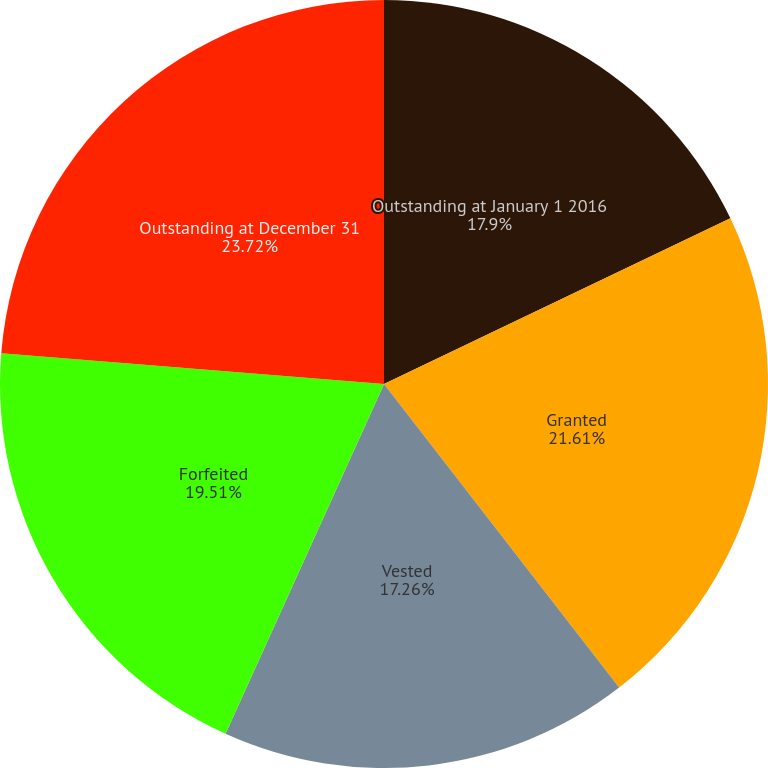<chart> <loc_0><loc_0><loc_500><loc_500><pie_chart><fcel>Outstanding at January 1 2016<fcel>Granted<fcel>Vested<fcel>Forfeited<fcel>Outstanding at December 31<nl><fcel>17.9%<fcel>21.61%<fcel>17.26%<fcel>19.51%<fcel>23.72%<nl></chart> 